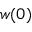Convert formula to latex. <formula><loc_0><loc_0><loc_500><loc_500>w ( 0 )</formula> 